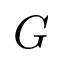Convert formula to latex. <formula><loc_0><loc_0><loc_500><loc_500>G</formula> 